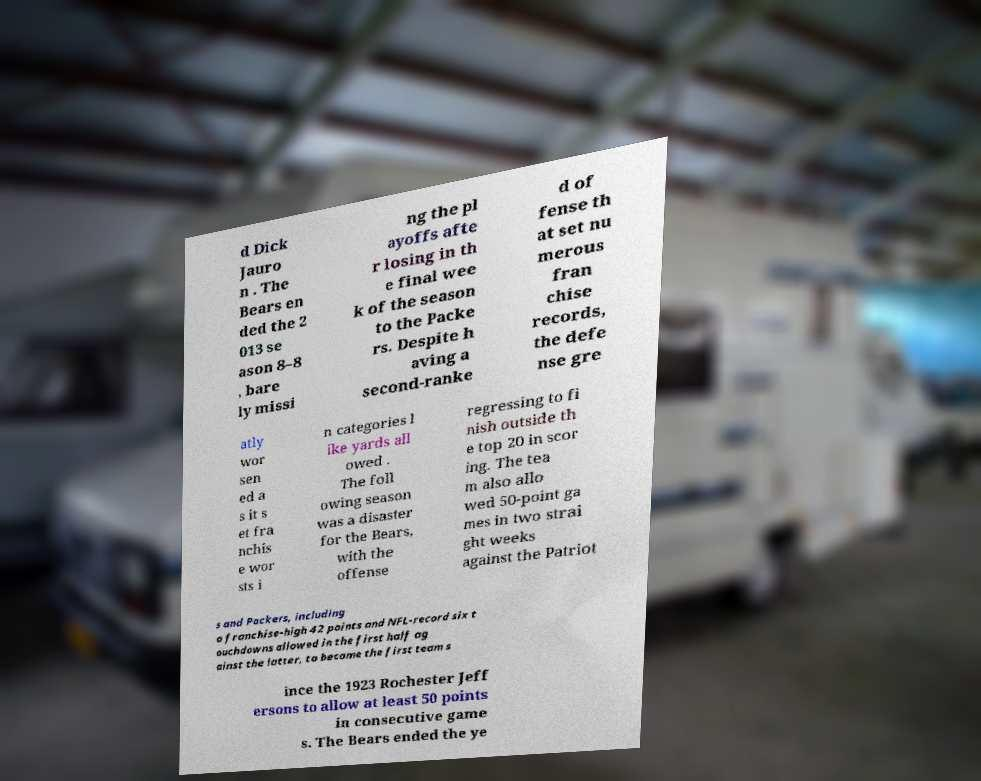There's text embedded in this image that I need extracted. Can you transcribe it verbatim? d Dick Jauro n . The Bears en ded the 2 013 se ason 8–8 , bare ly missi ng the pl ayoffs afte r losing in th e final wee k of the season to the Packe rs. Despite h aving a second-ranke d of fense th at set nu merous fran chise records, the defe nse gre atly wor sen ed a s it s et fra nchis e wor sts i n categories l ike yards all owed . The foll owing season was a disaster for the Bears, with the offense regressing to fi nish outside th e top 20 in scor ing. The tea m also allo wed 50-point ga mes in two strai ght weeks against the Patriot s and Packers, including a franchise-high 42 points and NFL-record six t ouchdowns allowed in the first half ag ainst the latter, to become the first team s ince the 1923 Rochester Jeff ersons to allow at least 50 points in consecutive game s. The Bears ended the ye 